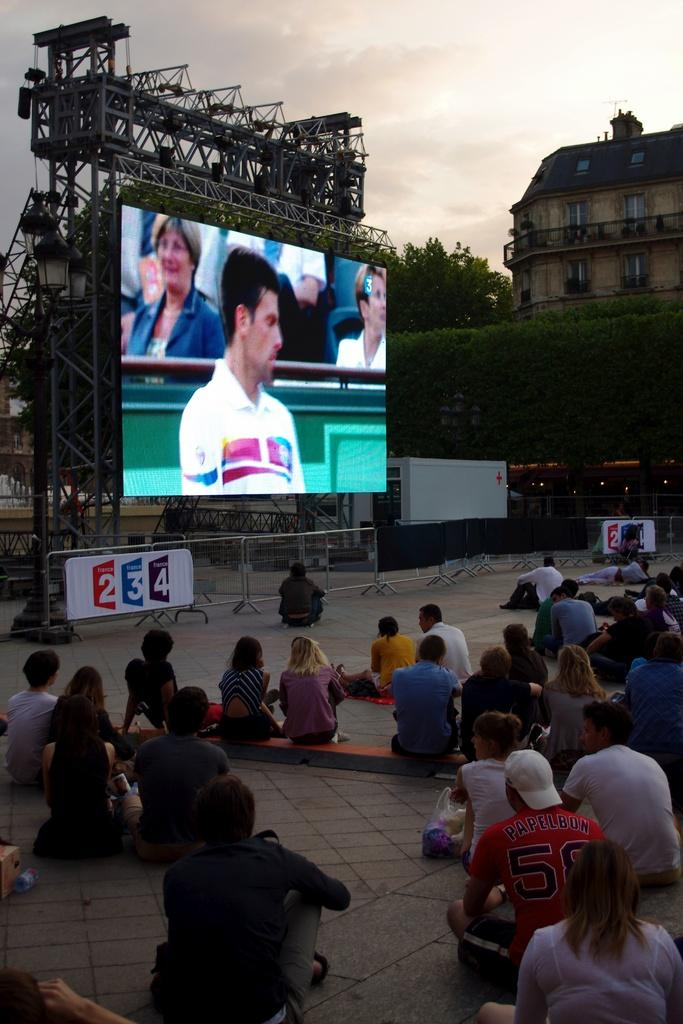<image>
Describe the image concisely. Some people watching a tennis match on a big screen with the numbers 234 visible. 